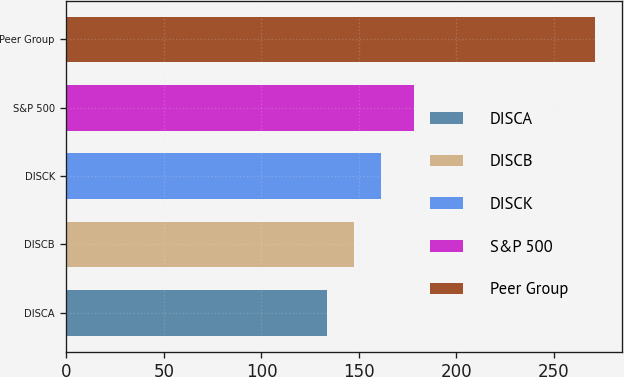Convert chart to OTSL. <chart><loc_0><loc_0><loc_500><loc_500><bar_chart><fcel>DISCA<fcel>DISCB<fcel>DISCK<fcel>S&P 500<fcel>Peer Group<nl><fcel>133.81<fcel>147.54<fcel>161.27<fcel>178.02<fcel>271.11<nl></chart> 